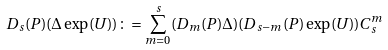Convert formula to latex. <formula><loc_0><loc_0><loc_500><loc_500>D _ { s } ( P ) ( \Delta \exp ( U ) ) \colon = \sum _ { m = 0 } ^ { s } ( D _ { m } ( P ) \Delta ) ( D _ { s - m } ( P ) \exp ( U ) ) C _ { s } ^ { m }</formula> 